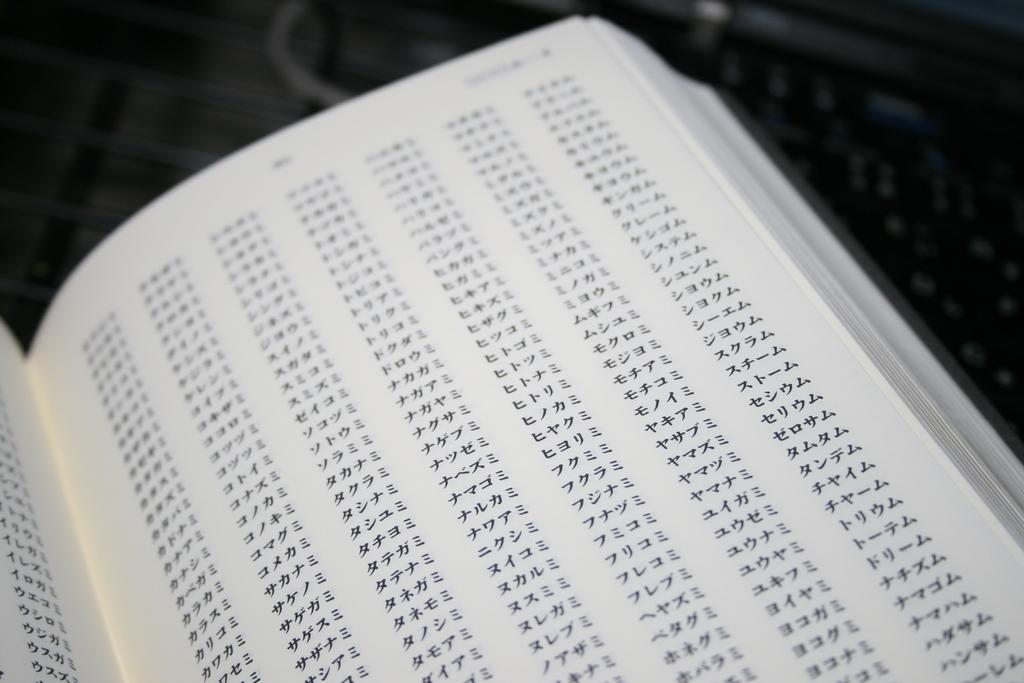What is the main subject in the image? There is an opened book in the image. How many cats are swimming in the book in the image? There are no cats or any swimming activity present in the image; it features an opened book. 